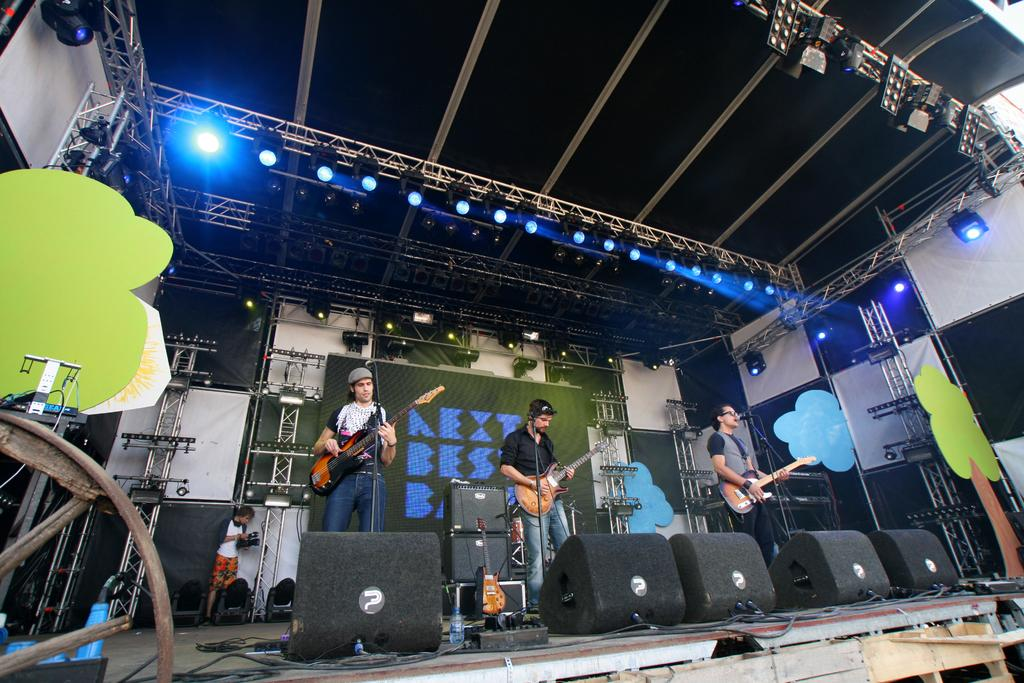What is happening in the image involving a group of people? There is a group of people in the image, and they are standing on a stage. What are the people holding in the image? The people are holding guitars in the image. What can be seen in the background of the image? There are lights visible in the background of the image. How does the yak interact with the people on the stage in the image? There is no yak present in the image; it only features a group of people standing on a stage with guitars. 